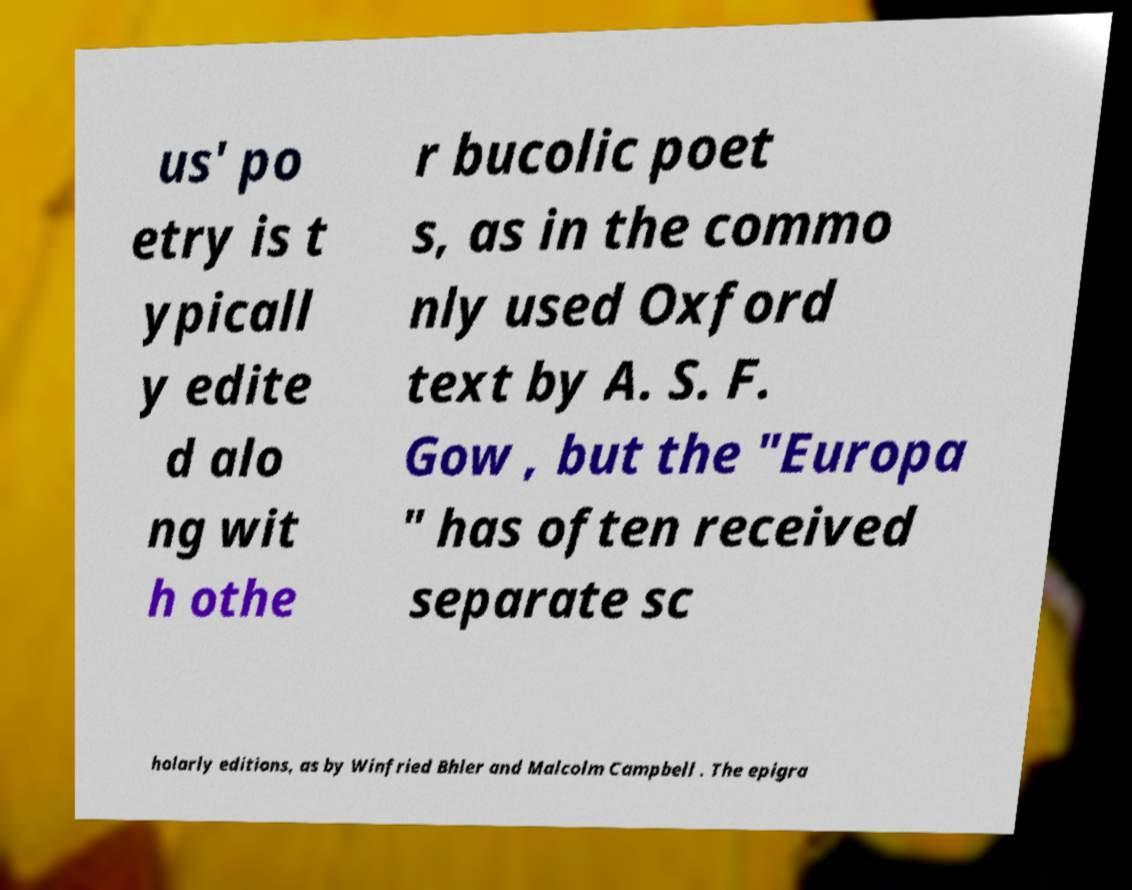Please identify and transcribe the text found in this image. us' po etry is t ypicall y edite d alo ng wit h othe r bucolic poet s, as in the commo nly used Oxford text by A. S. F. Gow , but the "Europa " has often received separate sc holarly editions, as by Winfried Bhler and Malcolm Campbell . The epigra 